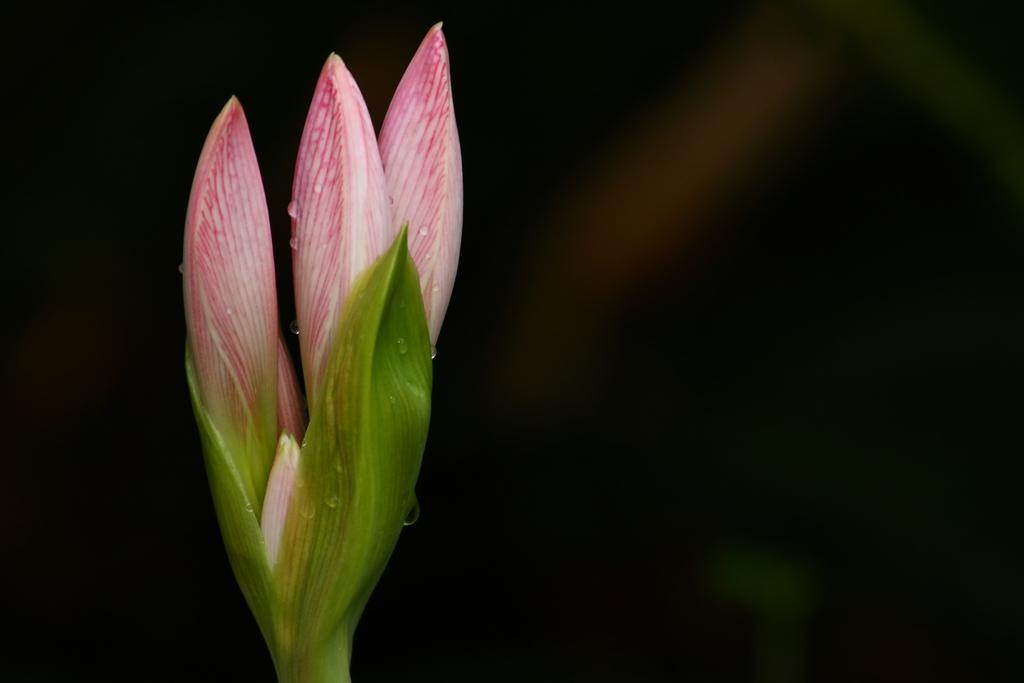In one or two sentences, can you explain what this image depicts? In this picture we can see three flower buds and there is a dark background. 